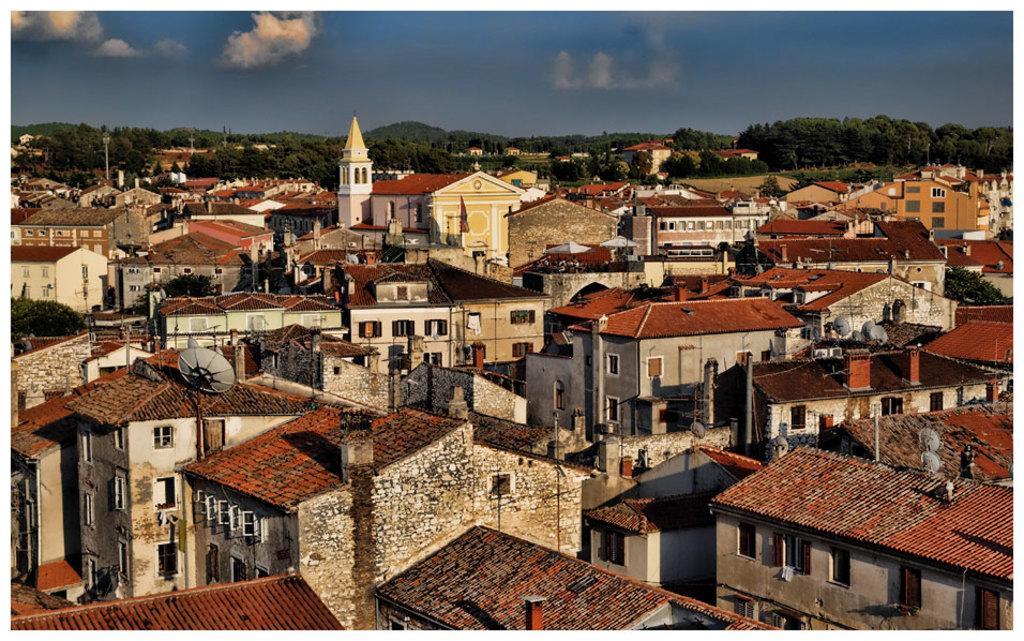Please provide a concise description of this image. In the image there are plenty of houses and in between the houses there is a church and in the background there are lot of trees and mountains. 